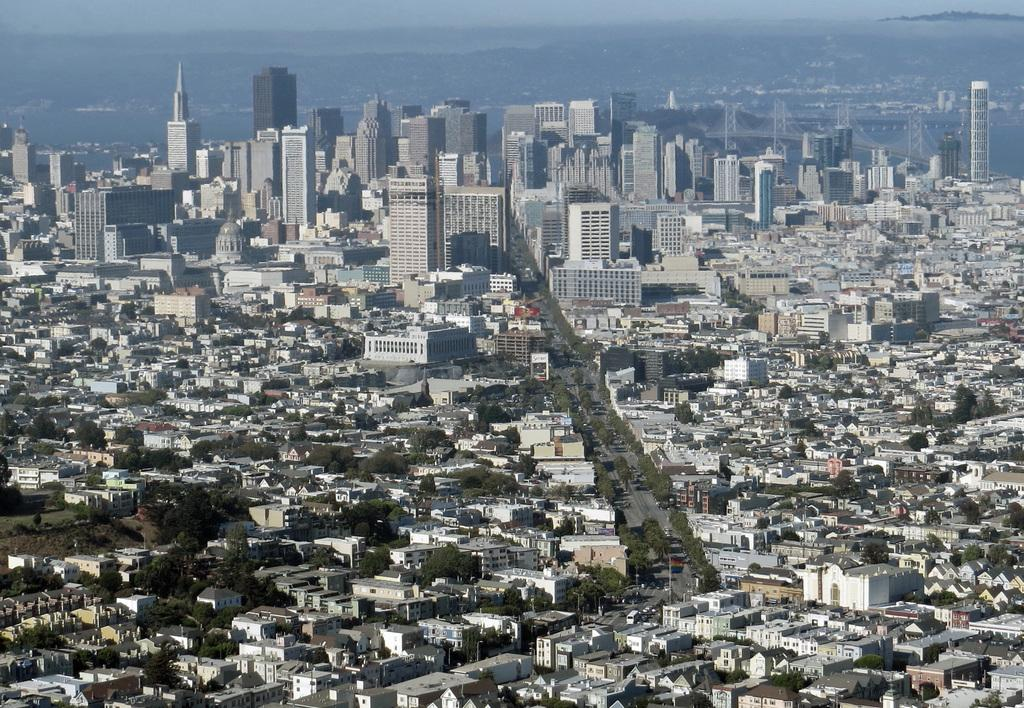What type of structures can be seen in the image? There are many buildings in the image. What other natural elements are visible in the image? There are trees in the image. What mode of transportation can be seen on the road in the image? Vehicles are present on the road in the image. From what perspective was the image taken? The image is taken from a top view. What type of sand can be seen on the playground in the image? There is no playground or sand present in the image. 